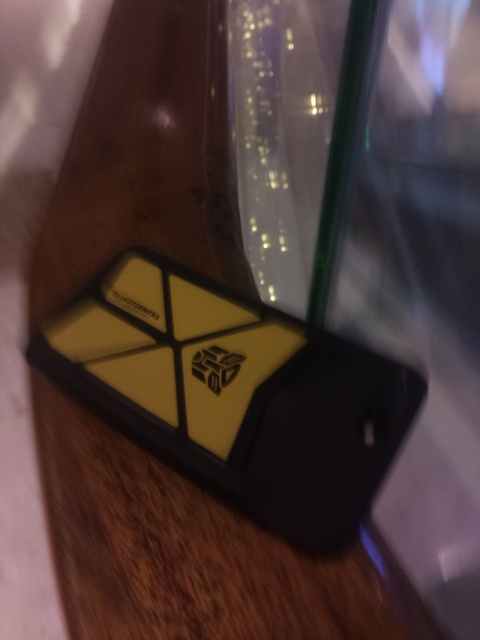What is the quality of this image? The quality of the image is below average due to its blurriness, low lighting, and lack of focus, resulting in a visual that is difficult to decipher clearly. 